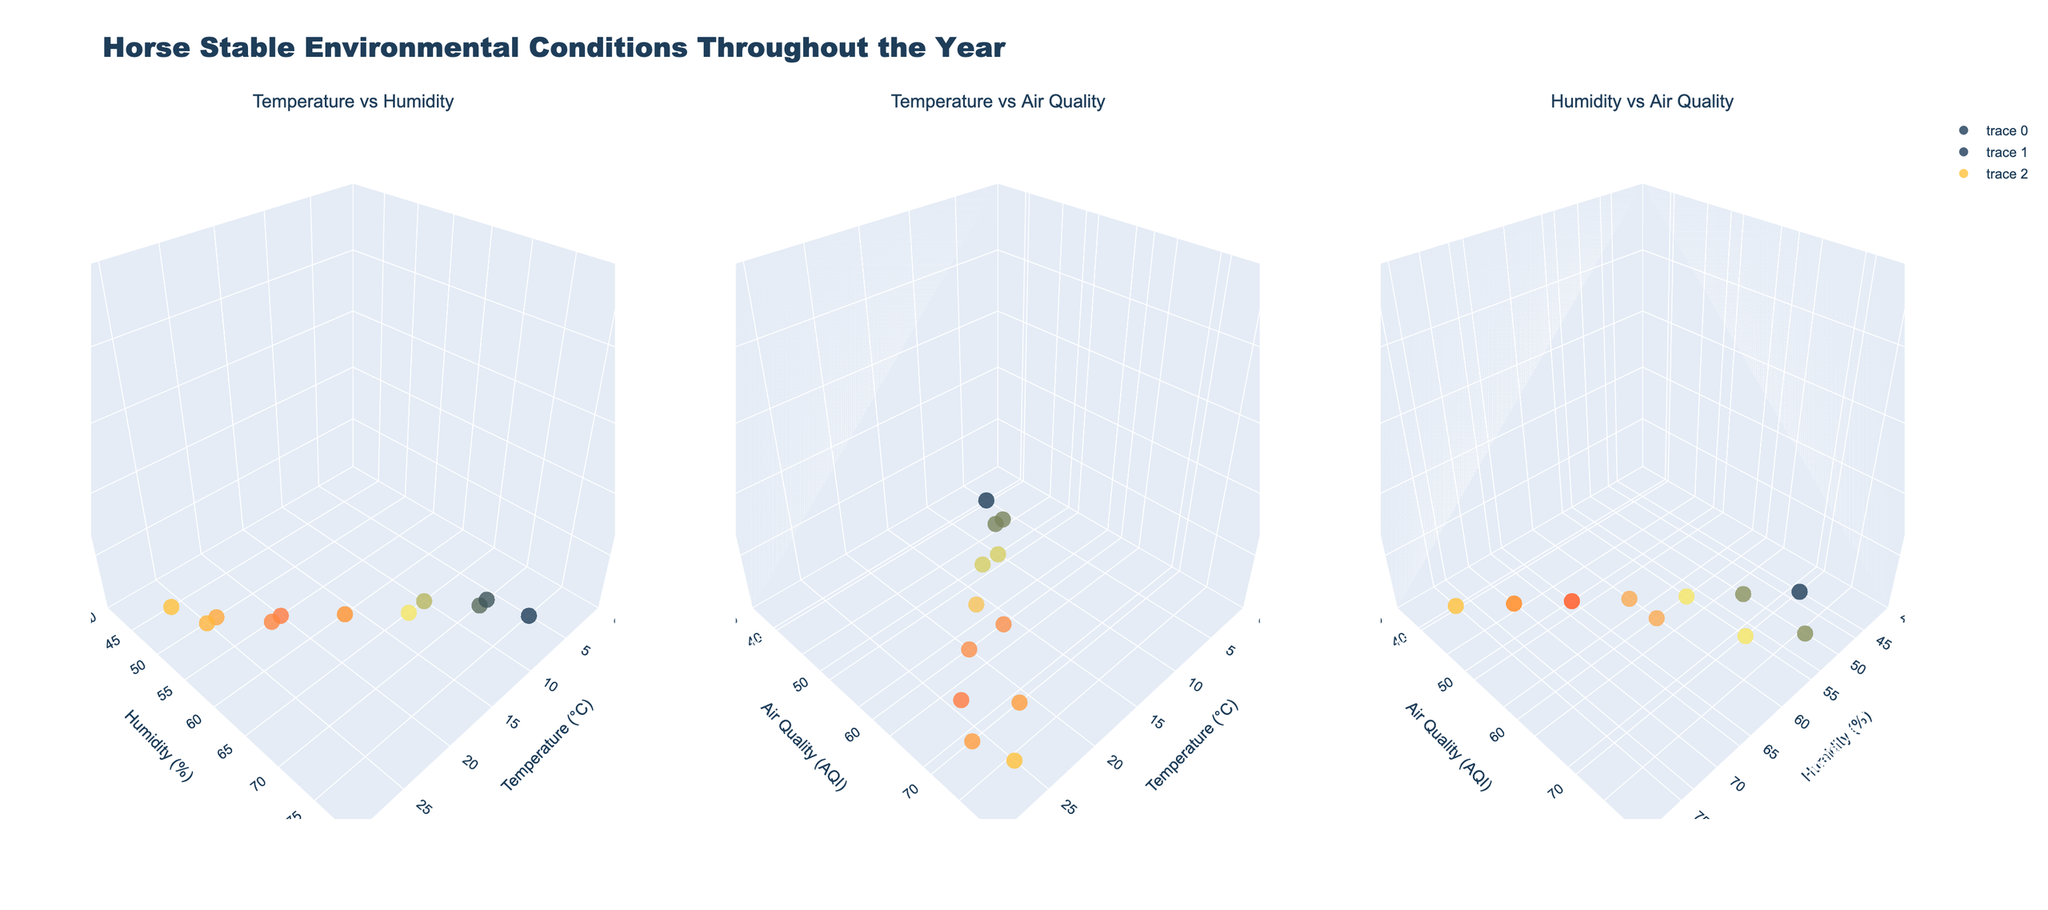What is the title of the figure? The title is displayed at the top of the figure. It reads "Horse Stable Environmental Conditions Throughout the Year".
Answer: Horse Stable Environmental Conditions Throughout the Year What is the range of the temperature axis in the first subplot? The range of the temperature axis in the first subplot, which is titled "Temperature vs Humidity", is displayed on the plot. It goes from 0°C to 30°C.
Answer: 0°C to 30°C Which month has the highest air quality index (AQI)? By referring to the "Temperature vs Air Quality" subplot, the highest AQI point can be observed. The month with the highest AQI is August with a value of 75.
Answer: August Which months show a temperature of below 10°C in the "Temperature vs Humidity" subplot? By identifying data points below 10°C on the x-axis of the "Temperature vs Humidity" subplot, the months January (5°C), February (7°C), and December (6°C) are observed.
Answer: January, February, December What is the temperature range represented in the second subplot? The second subplot, titled "Temperature vs Air Quality", shows the temperature range on the x-axis. The range starts from 0°C and goes up to 30°C.
Answer: 0°C to 30°C How does the humidity vary with temperature in the "Temperature vs Humidity" subplot? Observing the pattern in the "Temperature vs Humidity" plot, it is apparent that as temperatures increase, humidity tends to decrease. This is visible from points shifting downward along the y-axis as the x-axis values increase.
Answer: Humidity decreases as temperature increases Compare the air quality during June and July. Which month has better air quality? By referring to the "Temperature vs Air Quality" subplot, June has an AQI of 65 and July has an AQI of 70. Since a lower AQI indicates better air quality, June has better air quality than July.
Answer: June Which breed is focused on in September and how is the air quality during this month? In the "Temperature vs Air Quality" subplot, the data point for September (21°C) shows an AQI of 70. Hovering or referencing text can show that the breed focused on in September is Tennessee Walker.
Answer: Tennessee Walker, AQI is 70 What is the relationship between humidity and air quality in the third subplot? By looking at the "Humidity vs Air Quality" subplot, as humidity increases, the air quality index fluctuates within a limited range, suggesting there isn't a clear trend. The points are more scattered.
Answer: No clear trend 